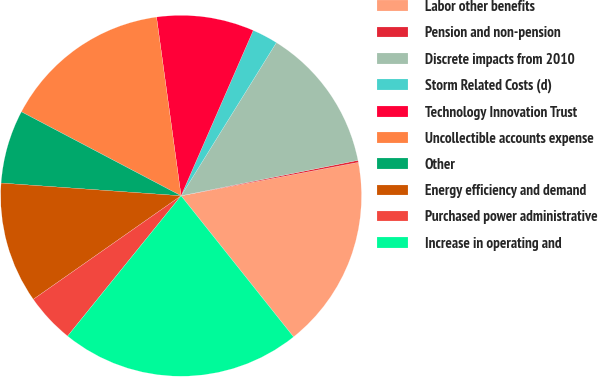<chart> <loc_0><loc_0><loc_500><loc_500><pie_chart><fcel>Labor other benefits<fcel>Pension and non-pension<fcel>Discrete impacts from 2010<fcel>Storm Related Costs (d)<fcel>Technology Innovation Trust<fcel>Uncollectible accounts expense<fcel>Other<fcel>Energy efficiency and demand<fcel>Purchased power administrative<fcel>Increase in operating and<nl><fcel>17.26%<fcel>0.18%<fcel>12.99%<fcel>2.31%<fcel>8.72%<fcel>15.12%<fcel>6.58%<fcel>10.85%<fcel>4.45%<fcel>21.53%<nl></chart> 